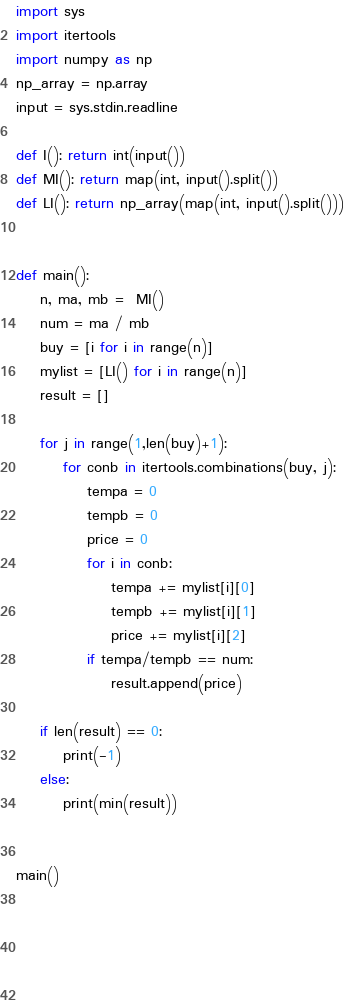Convert code to text. <code><loc_0><loc_0><loc_500><loc_500><_Python_>import sys
import itertools
import numpy as np
np_array = np.array
input = sys.stdin.readline
 
def I(): return int(input())
def MI(): return map(int, input().split())
def LI(): return np_array(map(int, input().split()))


def main():
    n, ma, mb =  MI()
    num = ma / mb
    buy = [i for i in range(n)]
    mylist = [LI() for i in range(n)]
    result = []
    
    for j in range(1,len(buy)+1):
        for conb in itertools.combinations(buy, j):
            tempa = 0
            tempb = 0
            price = 0
            for i in conb:
                tempa += mylist[i][0]
                tempb += mylist[i][1]
                price += mylist[i][2]
            if tempa/tempb == num:
                result.append(price)
                
    if len(result) == 0:
        print(-1)
    else:
        print(min(result))


main()



        
    </code> 